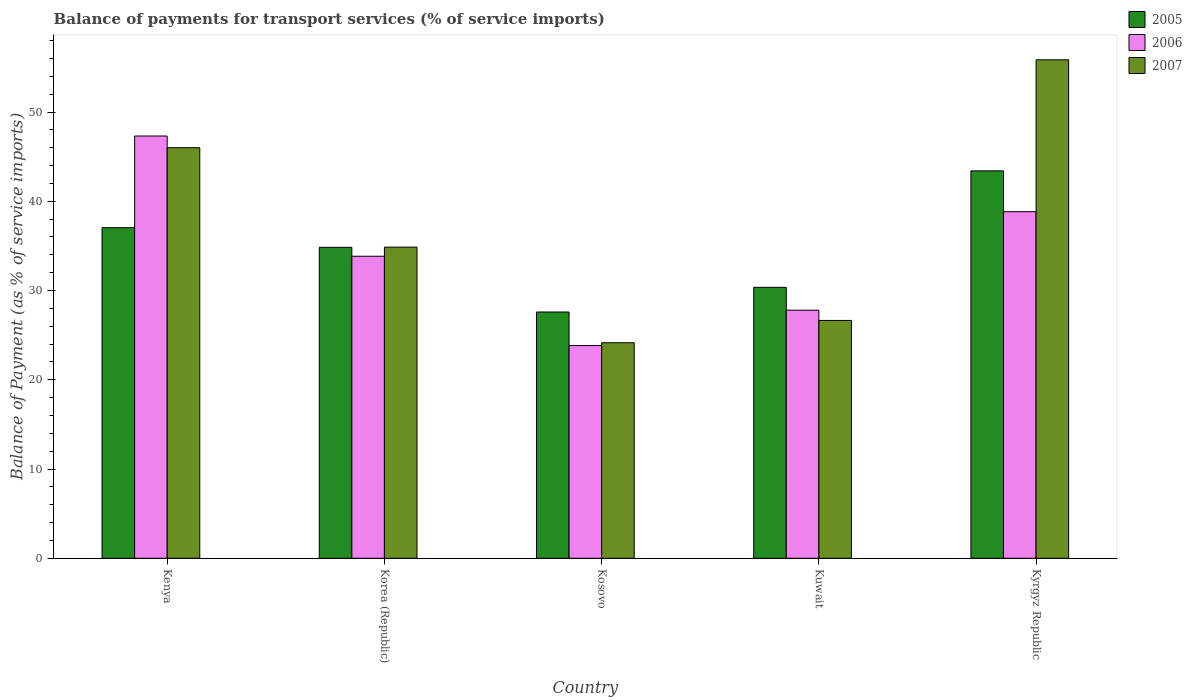Are the number of bars on each tick of the X-axis equal?
Offer a terse response. Yes. How many bars are there on the 3rd tick from the right?
Offer a very short reply. 3. What is the balance of payments for transport services in 2006 in Kenya?
Offer a terse response. 47.31. Across all countries, what is the maximum balance of payments for transport services in 2006?
Make the answer very short. 47.31. Across all countries, what is the minimum balance of payments for transport services in 2006?
Your answer should be very brief. 23.83. In which country was the balance of payments for transport services in 2005 maximum?
Give a very brief answer. Kyrgyz Republic. In which country was the balance of payments for transport services in 2007 minimum?
Provide a short and direct response. Kosovo. What is the total balance of payments for transport services in 2007 in the graph?
Make the answer very short. 187.51. What is the difference between the balance of payments for transport services in 2005 in Korea (Republic) and that in Kosovo?
Your answer should be very brief. 7.24. What is the difference between the balance of payments for transport services in 2007 in Kenya and the balance of payments for transport services in 2005 in Korea (Republic)?
Provide a succinct answer. 11.16. What is the average balance of payments for transport services in 2006 per country?
Provide a succinct answer. 34.32. What is the difference between the balance of payments for transport services of/in 2005 and balance of payments for transport services of/in 2006 in Kenya?
Your answer should be compact. -10.27. In how many countries, is the balance of payments for transport services in 2007 greater than 14 %?
Give a very brief answer. 5. What is the ratio of the balance of payments for transport services in 2007 in Kuwait to that in Kyrgyz Republic?
Your answer should be compact. 0.48. Is the balance of payments for transport services in 2007 in Korea (Republic) less than that in Kosovo?
Give a very brief answer. No. Is the difference between the balance of payments for transport services in 2005 in Kosovo and Kyrgyz Republic greater than the difference between the balance of payments for transport services in 2006 in Kosovo and Kyrgyz Republic?
Offer a terse response. No. What is the difference between the highest and the second highest balance of payments for transport services in 2007?
Give a very brief answer. -11.14. What is the difference between the highest and the lowest balance of payments for transport services in 2007?
Provide a short and direct response. 31.7. In how many countries, is the balance of payments for transport services in 2006 greater than the average balance of payments for transport services in 2006 taken over all countries?
Ensure brevity in your answer.  2. Is the sum of the balance of payments for transport services in 2005 in Korea (Republic) and Kuwait greater than the maximum balance of payments for transport services in 2006 across all countries?
Make the answer very short. Yes. What does the 2nd bar from the right in Kyrgyz Republic represents?
Give a very brief answer. 2006. Is it the case that in every country, the sum of the balance of payments for transport services in 2006 and balance of payments for transport services in 2005 is greater than the balance of payments for transport services in 2007?
Your response must be concise. Yes. How many countries are there in the graph?
Make the answer very short. 5. What is the difference between two consecutive major ticks on the Y-axis?
Offer a terse response. 10. Does the graph contain any zero values?
Ensure brevity in your answer.  No. Does the graph contain grids?
Your answer should be very brief. No. How many legend labels are there?
Make the answer very short. 3. What is the title of the graph?
Offer a terse response. Balance of payments for transport services (% of service imports). Does "2015" appear as one of the legend labels in the graph?
Provide a short and direct response. No. What is the label or title of the Y-axis?
Ensure brevity in your answer.  Balance of Payment (as % of service imports). What is the Balance of Payment (as % of service imports) of 2005 in Kenya?
Provide a short and direct response. 37.04. What is the Balance of Payment (as % of service imports) of 2006 in Kenya?
Give a very brief answer. 47.31. What is the Balance of Payment (as % of service imports) in 2007 in Kenya?
Your answer should be compact. 46. What is the Balance of Payment (as % of service imports) of 2005 in Korea (Republic)?
Your response must be concise. 34.84. What is the Balance of Payment (as % of service imports) in 2006 in Korea (Republic)?
Offer a terse response. 33.84. What is the Balance of Payment (as % of service imports) in 2007 in Korea (Republic)?
Keep it short and to the point. 34.86. What is the Balance of Payment (as % of service imports) in 2005 in Kosovo?
Provide a short and direct response. 27.59. What is the Balance of Payment (as % of service imports) of 2006 in Kosovo?
Offer a very short reply. 23.83. What is the Balance of Payment (as % of service imports) in 2007 in Kosovo?
Provide a short and direct response. 24.15. What is the Balance of Payment (as % of service imports) of 2005 in Kuwait?
Your response must be concise. 30.36. What is the Balance of Payment (as % of service imports) of 2006 in Kuwait?
Keep it short and to the point. 27.8. What is the Balance of Payment (as % of service imports) of 2007 in Kuwait?
Your response must be concise. 26.65. What is the Balance of Payment (as % of service imports) in 2005 in Kyrgyz Republic?
Your answer should be compact. 43.41. What is the Balance of Payment (as % of service imports) in 2006 in Kyrgyz Republic?
Provide a succinct answer. 38.83. What is the Balance of Payment (as % of service imports) in 2007 in Kyrgyz Republic?
Provide a succinct answer. 55.85. Across all countries, what is the maximum Balance of Payment (as % of service imports) in 2005?
Offer a terse response. 43.41. Across all countries, what is the maximum Balance of Payment (as % of service imports) of 2006?
Give a very brief answer. 47.31. Across all countries, what is the maximum Balance of Payment (as % of service imports) of 2007?
Offer a terse response. 55.85. Across all countries, what is the minimum Balance of Payment (as % of service imports) of 2005?
Give a very brief answer. 27.59. Across all countries, what is the minimum Balance of Payment (as % of service imports) of 2006?
Offer a very short reply. 23.83. Across all countries, what is the minimum Balance of Payment (as % of service imports) of 2007?
Offer a very short reply. 24.15. What is the total Balance of Payment (as % of service imports) in 2005 in the graph?
Your response must be concise. 173.23. What is the total Balance of Payment (as % of service imports) of 2006 in the graph?
Provide a succinct answer. 171.61. What is the total Balance of Payment (as % of service imports) of 2007 in the graph?
Your response must be concise. 187.51. What is the difference between the Balance of Payment (as % of service imports) in 2005 in Kenya and that in Korea (Republic)?
Give a very brief answer. 2.2. What is the difference between the Balance of Payment (as % of service imports) in 2006 in Kenya and that in Korea (Republic)?
Provide a succinct answer. 13.47. What is the difference between the Balance of Payment (as % of service imports) in 2007 in Kenya and that in Korea (Republic)?
Keep it short and to the point. 11.14. What is the difference between the Balance of Payment (as % of service imports) in 2005 in Kenya and that in Kosovo?
Your answer should be very brief. 9.44. What is the difference between the Balance of Payment (as % of service imports) of 2006 in Kenya and that in Kosovo?
Give a very brief answer. 23.48. What is the difference between the Balance of Payment (as % of service imports) of 2007 in Kenya and that in Kosovo?
Offer a very short reply. 21.85. What is the difference between the Balance of Payment (as % of service imports) in 2005 in Kenya and that in Kuwait?
Ensure brevity in your answer.  6.68. What is the difference between the Balance of Payment (as % of service imports) in 2006 in Kenya and that in Kuwait?
Your answer should be compact. 19.51. What is the difference between the Balance of Payment (as % of service imports) of 2007 in Kenya and that in Kuwait?
Provide a short and direct response. 19.35. What is the difference between the Balance of Payment (as % of service imports) in 2005 in Kenya and that in Kyrgyz Republic?
Provide a succinct answer. -6.37. What is the difference between the Balance of Payment (as % of service imports) in 2006 in Kenya and that in Kyrgyz Republic?
Keep it short and to the point. 8.48. What is the difference between the Balance of Payment (as % of service imports) of 2007 in Kenya and that in Kyrgyz Republic?
Your answer should be compact. -9.85. What is the difference between the Balance of Payment (as % of service imports) in 2005 in Korea (Republic) and that in Kosovo?
Your response must be concise. 7.24. What is the difference between the Balance of Payment (as % of service imports) in 2006 in Korea (Republic) and that in Kosovo?
Offer a very short reply. 10.01. What is the difference between the Balance of Payment (as % of service imports) in 2007 in Korea (Republic) and that in Kosovo?
Keep it short and to the point. 10.71. What is the difference between the Balance of Payment (as % of service imports) of 2005 in Korea (Republic) and that in Kuwait?
Provide a short and direct response. 4.48. What is the difference between the Balance of Payment (as % of service imports) of 2006 in Korea (Republic) and that in Kuwait?
Your response must be concise. 6.04. What is the difference between the Balance of Payment (as % of service imports) of 2007 in Korea (Republic) and that in Kuwait?
Your answer should be very brief. 8.21. What is the difference between the Balance of Payment (as % of service imports) of 2005 in Korea (Republic) and that in Kyrgyz Republic?
Give a very brief answer. -8.57. What is the difference between the Balance of Payment (as % of service imports) of 2006 in Korea (Republic) and that in Kyrgyz Republic?
Give a very brief answer. -4.99. What is the difference between the Balance of Payment (as % of service imports) in 2007 in Korea (Republic) and that in Kyrgyz Republic?
Ensure brevity in your answer.  -20.99. What is the difference between the Balance of Payment (as % of service imports) of 2005 in Kosovo and that in Kuwait?
Offer a very short reply. -2.76. What is the difference between the Balance of Payment (as % of service imports) of 2006 in Kosovo and that in Kuwait?
Make the answer very short. -3.96. What is the difference between the Balance of Payment (as % of service imports) in 2007 in Kosovo and that in Kuwait?
Your answer should be compact. -2.5. What is the difference between the Balance of Payment (as % of service imports) in 2005 in Kosovo and that in Kyrgyz Republic?
Keep it short and to the point. -15.81. What is the difference between the Balance of Payment (as % of service imports) of 2006 in Kosovo and that in Kyrgyz Republic?
Give a very brief answer. -15. What is the difference between the Balance of Payment (as % of service imports) in 2007 in Kosovo and that in Kyrgyz Republic?
Offer a terse response. -31.7. What is the difference between the Balance of Payment (as % of service imports) of 2005 in Kuwait and that in Kyrgyz Republic?
Offer a terse response. -13.05. What is the difference between the Balance of Payment (as % of service imports) in 2006 in Kuwait and that in Kyrgyz Republic?
Offer a terse response. -11.04. What is the difference between the Balance of Payment (as % of service imports) in 2007 in Kuwait and that in Kyrgyz Republic?
Keep it short and to the point. -29.2. What is the difference between the Balance of Payment (as % of service imports) of 2005 in Kenya and the Balance of Payment (as % of service imports) of 2006 in Korea (Republic)?
Your answer should be very brief. 3.2. What is the difference between the Balance of Payment (as % of service imports) in 2005 in Kenya and the Balance of Payment (as % of service imports) in 2007 in Korea (Republic)?
Offer a terse response. 2.18. What is the difference between the Balance of Payment (as % of service imports) of 2006 in Kenya and the Balance of Payment (as % of service imports) of 2007 in Korea (Republic)?
Offer a terse response. 12.45. What is the difference between the Balance of Payment (as % of service imports) in 2005 in Kenya and the Balance of Payment (as % of service imports) in 2006 in Kosovo?
Give a very brief answer. 13.21. What is the difference between the Balance of Payment (as % of service imports) in 2005 in Kenya and the Balance of Payment (as % of service imports) in 2007 in Kosovo?
Your answer should be very brief. 12.89. What is the difference between the Balance of Payment (as % of service imports) in 2006 in Kenya and the Balance of Payment (as % of service imports) in 2007 in Kosovo?
Your response must be concise. 23.16. What is the difference between the Balance of Payment (as % of service imports) of 2005 in Kenya and the Balance of Payment (as % of service imports) of 2006 in Kuwait?
Your answer should be compact. 9.24. What is the difference between the Balance of Payment (as % of service imports) of 2005 in Kenya and the Balance of Payment (as % of service imports) of 2007 in Kuwait?
Offer a very short reply. 10.39. What is the difference between the Balance of Payment (as % of service imports) of 2006 in Kenya and the Balance of Payment (as % of service imports) of 2007 in Kuwait?
Give a very brief answer. 20.66. What is the difference between the Balance of Payment (as % of service imports) of 2005 in Kenya and the Balance of Payment (as % of service imports) of 2006 in Kyrgyz Republic?
Your answer should be very brief. -1.79. What is the difference between the Balance of Payment (as % of service imports) of 2005 in Kenya and the Balance of Payment (as % of service imports) of 2007 in Kyrgyz Republic?
Make the answer very short. -18.81. What is the difference between the Balance of Payment (as % of service imports) of 2006 in Kenya and the Balance of Payment (as % of service imports) of 2007 in Kyrgyz Republic?
Keep it short and to the point. -8.54. What is the difference between the Balance of Payment (as % of service imports) in 2005 in Korea (Republic) and the Balance of Payment (as % of service imports) in 2006 in Kosovo?
Provide a succinct answer. 11. What is the difference between the Balance of Payment (as % of service imports) of 2005 in Korea (Republic) and the Balance of Payment (as % of service imports) of 2007 in Kosovo?
Make the answer very short. 10.69. What is the difference between the Balance of Payment (as % of service imports) in 2006 in Korea (Republic) and the Balance of Payment (as % of service imports) in 2007 in Kosovo?
Offer a very short reply. 9.69. What is the difference between the Balance of Payment (as % of service imports) of 2005 in Korea (Republic) and the Balance of Payment (as % of service imports) of 2006 in Kuwait?
Your answer should be compact. 7.04. What is the difference between the Balance of Payment (as % of service imports) of 2005 in Korea (Republic) and the Balance of Payment (as % of service imports) of 2007 in Kuwait?
Provide a succinct answer. 8.19. What is the difference between the Balance of Payment (as % of service imports) in 2006 in Korea (Republic) and the Balance of Payment (as % of service imports) in 2007 in Kuwait?
Ensure brevity in your answer.  7.19. What is the difference between the Balance of Payment (as % of service imports) of 2005 in Korea (Republic) and the Balance of Payment (as % of service imports) of 2006 in Kyrgyz Republic?
Provide a succinct answer. -3.99. What is the difference between the Balance of Payment (as % of service imports) in 2005 in Korea (Republic) and the Balance of Payment (as % of service imports) in 2007 in Kyrgyz Republic?
Your answer should be very brief. -21.01. What is the difference between the Balance of Payment (as % of service imports) in 2006 in Korea (Republic) and the Balance of Payment (as % of service imports) in 2007 in Kyrgyz Republic?
Offer a very short reply. -22.01. What is the difference between the Balance of Payment (as % of service imports) of 2005 in Kosovo and the Balance of Payment (as % of service imports) of 2006 in Kuwait?
Ensure brevity in your answer.  -0.2. What is the difference between the Balance of Payment (as % of service imports) in 2005 in Kosovo and the Balance of Payment (as % of service imports) in 2007 in Kuwait?
Provide a short and direct response. 0.95. What is the difference between the Balance of Payment (as % of service imports) of 2006 in Kosovo and the Balance of Payment (as % of service imports) of 2007 in Kuwait?
Offer a very short reply. -2.81. What is the difference between the Balance of Payment (as % of service imports) in 2005 in Kosovo and the Balance of Payment (as % of service imports) in 2006 in Kyrgyz Republic?
Your answer should be compact. -11.24. What is the difference between the Balance of Payment (as % of service imports) of 2005 in Kosovo and the Balance of Payment (as % of service imports) of 2007 in Kyrgyz Republic?
Make the answer very short. -28.26. What is the difference between the Balance of Payment (as % of service imports) of 2006 in Kosovo and the Balance of Payment (as % of service imports) of 2007 in Kyrgyz Republic?
Keep it short and to the point. -32.02. What is the difference between the Balance of Payment (as % of service imports) in 2005 in Kuwait and the Balance of Payment (as % of service imports) in 2006 in Kyrgyz Republic?
Give a very brief answer. -8.48. What is the difference between the Balance of Payment (as % of service imports) of 2005 in Kuwait and the Balance of Payment (as % of service imports) of 2007 in Kyrgyz Republic?
Provide a short and direct response. -25.49. What is the difference between the Balance of Payment (as % of service imports) of 2006 in Kuwait and the Balance of Payment (as % of service imports) of 2007 in Kyrgyz Republic?
Keep it short and to the point. -28.05. What is the average Balance of Payment (as % of service imports) of 2005 per country?
Provide a succinct answer. 34.65. What is the average Balance of Payment (as % of service imports) in 2006 per country?
Make the answer very short. 34.32. What is the average Balance of Payment (as % of service imports) of 2007 per country?
Provide a succinct answer. 37.5. What is the difference between the Balance of Payment (as % of service imports) of 2005 and Balance of Payment (as % of service imports) of 2006 in Kenya?
Make the answer very short. -10.27. What is the difference between the Balance of Payment (as % of service imports) in 2005 and Balance of Payment (as % of service imports) in 2007 in Kenya?
Give a very brief answer. -8.96. What is the difference between the Balance of Payment (as % of service imports) of 2006 and Balance of Payment (as % of service imports) of 2007 in Kenya?
Keep it short and to the point. 1.31. What is the difference between the Balance of Payment (as % of service imports) in 2005 and Balance of Payment (as % of service imports) in 2006 in Korea (Republic)?
Your response must be concise. 1. What is the difference between the Balance of Payment (as % of service imports) in 2005 and Balance of Payment (as % of service imports) in 2007 in Korea (Republic)?
Keep it short and to the point. -0.02. What is the difference between the Balance of Payment (as % of service imports) in 2006 and Balance of Payment (as % of service imports) in 2007 in Korea (Republic)?
Your answer should be very brief. -1.02. What is the difference between the Balance of Payment (as % of service imports) in 2005 and Balance of Payment (as % of service imports) in 2006 in Kosovo?
Keep it short and to the point. 3.76. What is the difference between the Balance of Payment (as % of service imports) of 2005 and Balance of Payment (as % of service imports) of 2007 in Kosovo?
Your answer should be compact. 3.44. What is the difference between the Balance of Payment (as % of service imports) in 2006 and Balance of Payment (as % of service imports) in 2007 in Kosovo?
Provide a short and direct response. -0.32. What is the difference between the Balance of Payment (as % of service imports) of 2005 and Balance of Payment (as % of service imports) of 2006 in Kuwait?
Make the answer very short. 2.56. What is the difference between the Balance of Payment (as % of service imports) in 2005 and Balance of Payment (as % of service imports) in 2007 in Kuwait?
Your answer should be very brief. 3.71. What is the difference between the Balance of Payment (as % of service imports) in 2006 and Balance of Payment (as % of service imports) in 2007 in Kuwait?
Give a very brief answer. 1.15. What is the difference between the Balance of Payment (as % of service imports) in 2005 and Balance of Payment (as % of service imports) in 2006 in Kyrgyz Republic?
Offer a very short reply. 4.57. What is the difference between the Balance of Payment (as % of service imports) of 2005 and Balance of Payment (as % of service imports) of 2007 in Kyrgyz Republic?
Your answer should be compact. -12.44. What is the difference between the Balance of Payment (as % of service imports) in 2006 and Balance of Payment (as % of service imports) in 2007 in Kyrgyz Republic?
Your answer should be very brief. -17.02. What is the ratio of the Balance of Payment (as % of service imports) in 2005 in Kenya to that in Korea (Republic)?
Your answer should be compact. 1.06. What is the ratio of the Balance of Payment (as % of service imports) in 2006 in Kenya to that in Korea (Republic)?
Keep it short and to the point. 1.4. What is the ratio of the Balance of Payment (as % of service imports) of 2007 in Kenya to that in Korea (Republic)?
Keep it short and to the point. 1.32. What is the ratio of the Balance of Payment (as % of service imports) in 2005 in Kenya to that in Kosovo?
Keep it short and to the point. 1.34. What is the ratio of the Balance of Payment (as % of service imports) in 2006 in Kenya to that in Kosovo?
Your answer should be very brief. 1.99. What is the ratio of the Balance of Payment (as % of service imports) of 2007 in Kenya to that in Kosovo?
Your answer should be very brief. 1.9. What is the ratio of the Balance of Payment (as % of service imports) in 2005 in Kenya to that in Kuwait?
Offer a very short reply. 1.22. What is the ratio of the Balance of Payment (as % of service imports) in 2006 in Kenya to that in Kuwait?
Offer a terse response. 1.7. What is the ratio of the Balance of Payment (as % of service imports) of 2007 in Kenya to that in Kuwait?
Your response must be concise. 1.73. What is the ratio of the Balance of Payment (as % of service imports) of 2005 in Kenya to that in Kyrgyz Republic?
Ensure brevity in your answer.  0.85. What is the ratio of the Balance of Payment (as % of service imports) in 2006 in Kenya to that in Kyrgyz Republic?
Your answer should be compact. 1.22. What is the ratio of the Balance of Payment (as % of service imports) in 2007 in Kenya to that in Kyrgyz Republic?
Your answer should be compact. 0.82. What is the ratio of the Balance of Payment (as % of service imports) in 2005 in Korea (Republic) to that in Kosovo?
Keep it short and to the point. 1.26. What is the ratio of the Balance of Payment (as % of service imports) of 2006 in Korea (Republic) to that in Kosovo?
Offer a terse response. 1.42. What is the ratio of the Balance of Payment (as % of service imports) of 2007 in Korea (Republic) to that in Kosovo?
Your response must be concise. 1.44. What is the ratio of the Balance of Payment (as % of service imports) of 2005 in Korea (Republic) to that in Kuwait?
Your response must be concise. 1.15. What is the ratio of the Balance of Payment (as % of service imports) in 2006 in Korea (Republic) to that in Kuwait?
Make the answer very short. 1.22. What is the ratio of the Balance of Payment (as % of service imports) of 2007 in Korea (Republic) to that in Kuwait?
Make the answer very short. 1.31. What is the ratio of the Balance of Payment (as % of service imports) of 2005 in Korea (Republic) to that in Kyrgyz Republic?
Offer a terse response. 0.8. What is the ratio of the Balance of Payment (as % of service imports) of 2006 in Korea (Republic) to that in Kyrgyz Republic?
Your answer should be compact. 0.87. What is the ratio of the Balance of Payment (as % of service imports) of 2007 in Korea (Republic) to that in Kyrgyz Republic?
Keep it short and to the point. 0.62. What is the ratio of the Balance of Payment (as % of service imports) of 2005 in Kosovo to that in Kuwait?
Provide a succinct answer. 0.91. What is the ratio of the Balance of Payment (as % of service imports) in 2006 in Kosovo to that in Kuwait?
Keep it short and to the point. 0.86. What is the ratio of the Balance of Payment (as % of service imports) in 2007 in Kosovo to that in Kuwait?
Your answer should be compact. 0.91. What is the ratio of the Balance of Payment (as % of service imports) in 2005 in Kosovo to that in Kyrgyz Republic?
Provide a short and direct response. 0.64. What is the ratio of the Balance of Payment (as % of service imports) of 2006 in Kosovo to that in Kyrgyz Republic?
Give a very brief answer. 0.61. What is the ratio of the Balance of Payment (as % of service imports) of 2007 in Kosovo to that in Kyrgyz Republic?
Provide a short and direct response. 0.43. What is the ratio of the Balance of Payment (as % of service imports) of 2005 in Kuwait to that in Kyrgyz Republic?
Give a very brief answer. 0.7. What is the ratio of the Balance of Payment (as % of service imports) of 2006 in Kuwait to that in Kyrgyz Republic?
Provide a short and direct response. 0.72. What is the ratio of the Balance of Payment (as % of service imports) in 2007 in Kuwait to that in Kyrgyz Republic?
Your answer should be very brief. 0.48. What is the difference between the highest and the second highest Balance of Payment (as % of service imports) in 2005?
Your answer should be very brief. 6.37. What is the difference between the highest and the second highest Balance of Payment (as % of service imports) of 2006?
Provide a short and direct response. 8.48. What is the difference between the highest and the second highest Balance of Payment (as % of service imports) in 2007?
Give a very brief answer. 9.85. What is the difference between the highest and the lowest Balance of Payment (as % of service imports) in 2005?
Give a very brief answer. 15.81. What is the difference between the highest and the lowest Balance of Payment (as % of service imports) of 2006?
Offer a terse response. 23.48. What is the difference between the highest and the lowest Balance of Payment (as % of service imports) of 2007?
Offer a very short reply. 31.7. 